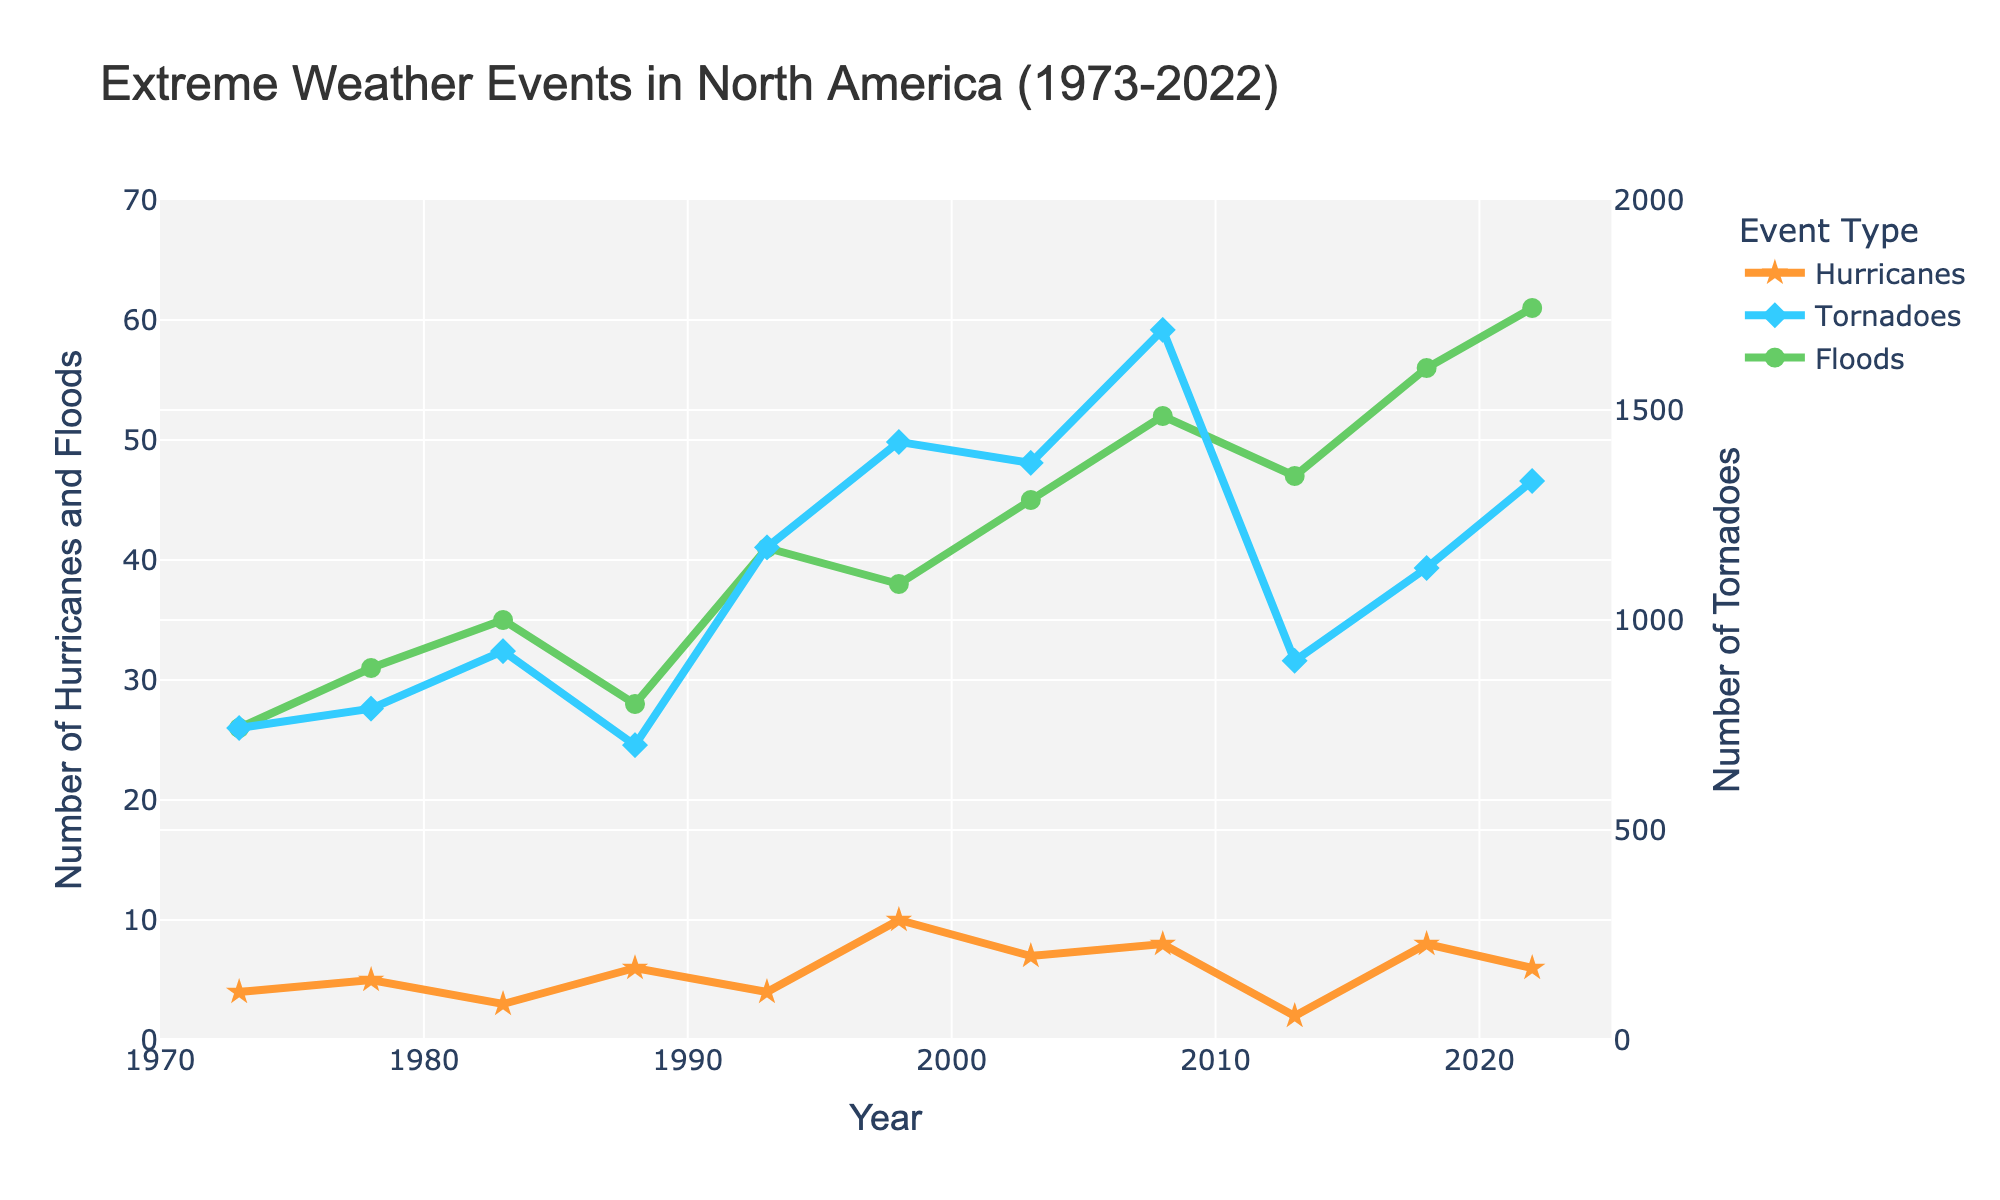Which year had the highest number of hurricanes? Based on the plot, we look for the peak point in the "Hurricanes" line. The highest point is in 1998.
Answer: 1998 What is the total number of hurricanes from 1973 to 2022? Sum all the hurricane values from the data. 4 + 5 + 3 + 6 + 4 + 10 + 7 + 8 + 2 + 8 + 6 = 63.
Answer: 63 In which year were the number of tornadoes closest to 1000? Locate the points along the "Tornadoes" line and find the year closest to 1000. From the plot, 2013 had 903 tornadoes.
Answer: 2013 Between 1973 and 2018, which type of extreme weather event showed the most increase? Compare the 1973 and 2018 values for each event type: Hurricanes (4 to 8), Tornadoes (743 to 1124), Floods (26 to 56). The increase in floods (56 - 26) is 30, which is the most significant.
Answer: Floods What is the average number of floods per year over the 50-year period? Average is calculated by summing the flood values and then dividing by the number of years. Sum = 26 + 31 + 35 + 28 + 41 + 38 + 45 + 52 + 47 + 56 + 61 = 460. Divide by 11 years = 460/11 = ~41.8.
Answer: ~41.8 How many more tornadoes were there in 2008 compared to 1993? Find the difference in tornado counts: 2008 (1691) - 1993 (1173) = 518.
Answer: 518 Which year had the lowest number of floods? From the plot, identify the lowest point on the "Floods" line, which is in 1973 with 26 floods.
Answer: 1973 Is there any year where both hurricanes and floods reached their respective peaks simultaneously? Compare the peak points of hurricanes and floods. They do not coincide. Hurricanes' peak is in 1998 and floods' peak is in 2022.
Answer: No Which event had the least variability over the years? Assess the fluctuations in the trend lines. The line for hurricanes appears to have the least variability compared to tornadoes and floods.
Answer: Hurricanes 